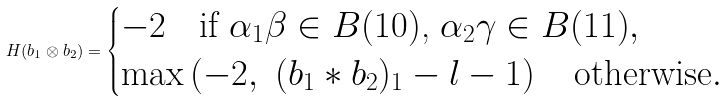Convert formula to latex. <formula><loc_0><loc_0><loc_500><loc_500>H ( b _ { 1 } \otimes b _ { 2 } ) = \begin{cases} - 2 \quad \text {if $\alpha_{1}\beta\in B(10)$, $\alpha_{2}\gamma \in B(11)$} , \\ \max \left ( - 2 , \ ( b _ { 1 } * b _ { 2 } ) _ { 1 } - l - 1 \right ) \quad \text {otherwise} . \end{cases}</formula> 